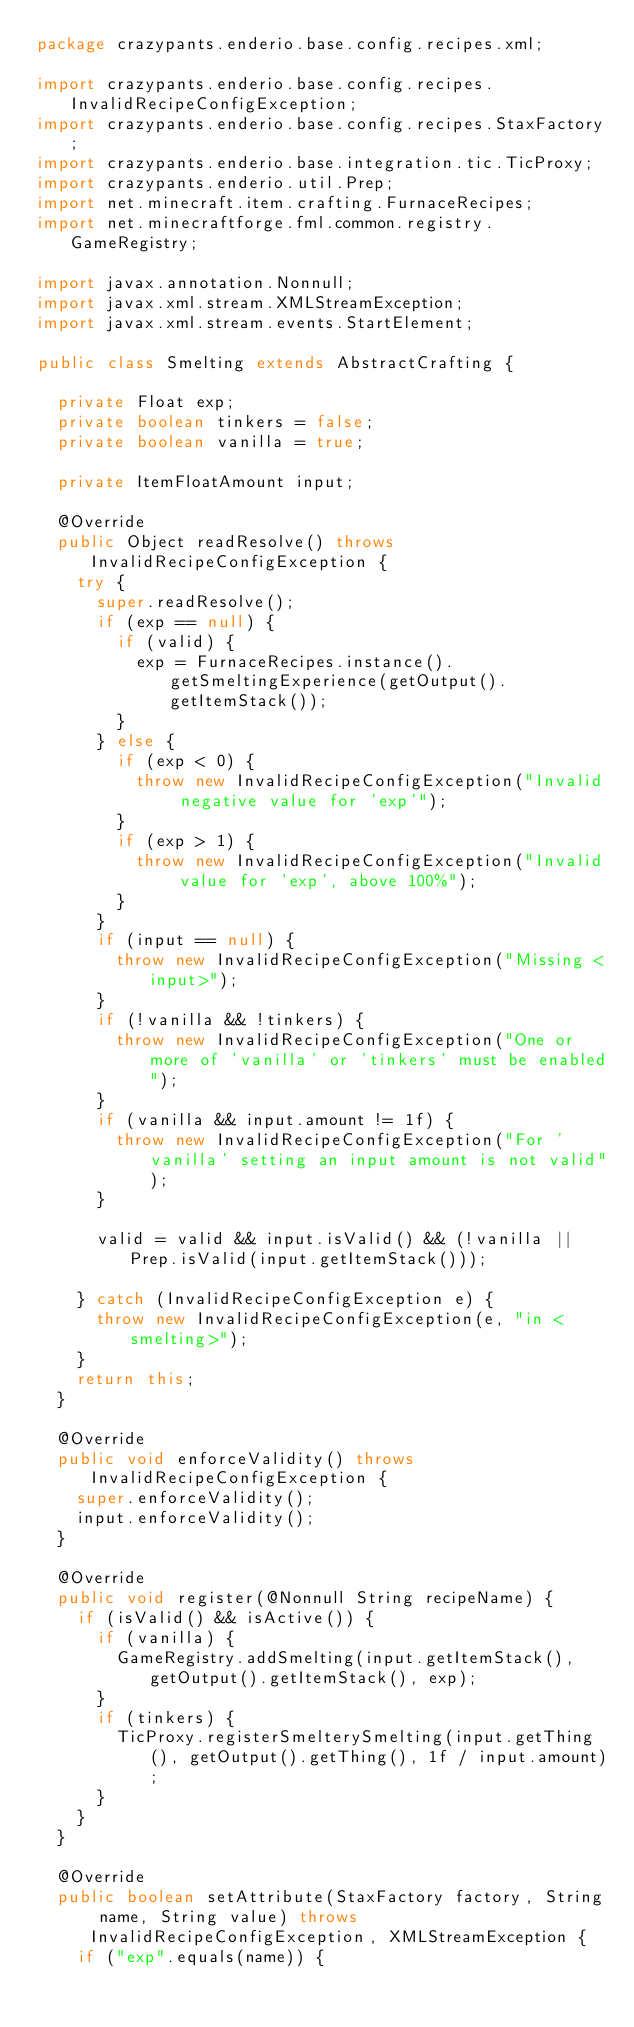Convert code to text. <code><loc_0><loc_0><loc_500><loc_500><_Java_>package crazypants.enderio.base.config.recipes.xml;

import crazypants.enderio.base.config.recipes.InvalidRecipeConfigException;
import crazypants.enderio.base.config.recipes.StaxFactory;
import crazypants.enderio.base.integration.tic.TicProxy;
import crazypants.enderio.util.Prep;
import net.minecraft.item.crafting.FurnaceRecipes;
import net.minecraftforge.fml.common.registry.GameRegistry;

import javax.annotation.Nonnull;
import javax.xml.stream.XMLStreamException;
import javax.xml.stream.events.StartElement;

public class Smelting extends AbstractCrafting {

  private Float exp;
  private boolean tinkers = false;
  private boolean vanilla = true;

  private ItemFloatAmount input;

  @Override
  public Object readResolve() throws InvalidRecipeConfigException {
    try {
      super.readResolve();
      if (exp == null) {
        if (valid) {
          exp = FurnaceRecipes.instance().getSmeltingExperience(getOutput().getItemStack());
        }
      } else {
        if (exp < 0) {
          throw new InvalidRecipeConfigException("Invalid negative value for 'exp'");
        }
        if (exp > 1) {
          throw new InvalidRecipeConfigException("Invalid value for 'exp', above 100%");
        }
      }
      if (input == null) {
        throw new InvalidRecipeConfigException("Missing <input>");
      }
      if (!vanilla && !tinkers) {
        throw new InvalidRecipeConfigException("One or more of 'vanilla' or 'tinkers' must be enabled");
      }
      if (vanilla && input.amount != 1f) {
        throw new InvalidRecipeConfigException("For 'vanilla' setting an input amount is not valid");
      }

      valid = valid && input.isValid() && (!vanilla || Prep.isValid(input.getItemStack()));

    } catch (InvalidRecipeConfigException e) {
      throw new InvalidRecipeConfigException(e, "in <smelting>");
    }
    return this;
  }

  @Override
  public void enforceValidity() throws InvalidRecipeConfigException {
    super.enforceValidity();
    input.enforceValidity();
  }

  @Override
  public void register(@Nonnull String recipeName) {
    if (isValid() && isActive()) {
      if (vanilla) {
        GameRegistry.addSmelting(input.getItemStack(), getOutput().getItemStack(), exp);
      }
      if (tinkers) {
        TicProxy.registerSmelterySmelting(input.getThing(), getOutput().getThing(), 1f / input.amount);
      }
    }
  }

  @Override
  public boolean setAttribute(StaxFactory factory, String name, String value) throws InvalidRecipeConfigException, XMLStreamException {
    if ("exp".equals(name)) {</code> 